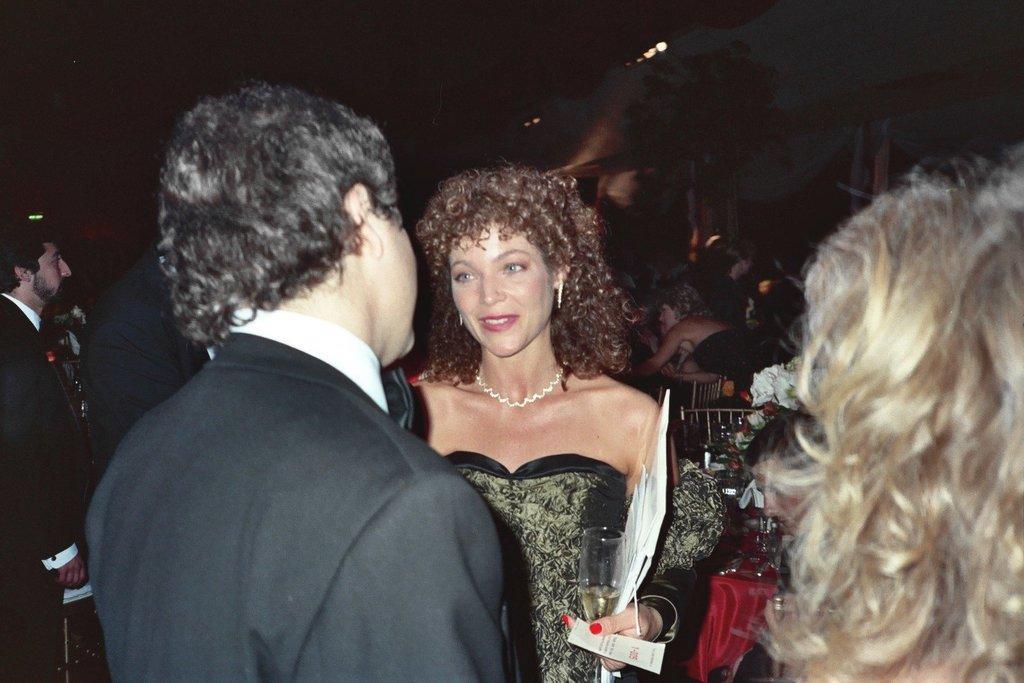Can you describe this image briefly? Here in this picture, in the front we can see a group of people standing over a place and men are wearing suits and the woman in the middle is smiling and carrying a glass and a file in her hand and behind her we can see other number of people sitting over there. 